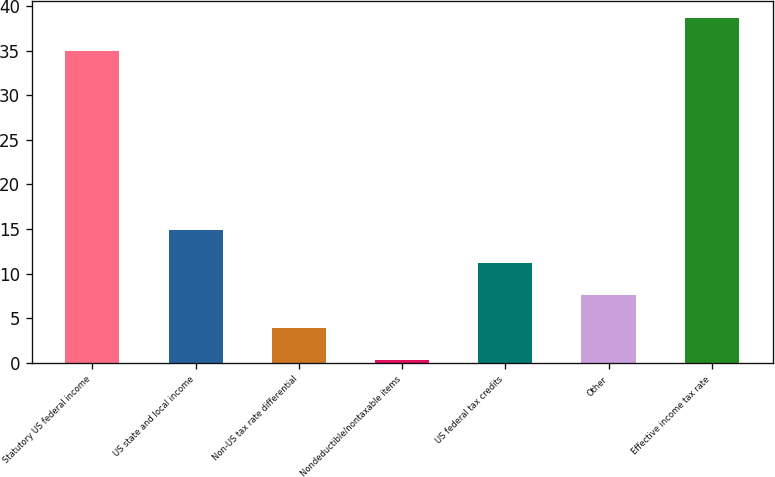<chart> <loc_0><loc_0><loc_500><loc_500><bar_chart><fcel>Statutory US federal income<fcel>US state and local income<fcel>Non-US tax rate differential<fcel>Nondeductible/nontaxable items<fcel>US federal tax credits<fcel>Other<fcel>Effective income tax rate<nl><fcel>35<fcel>14.9<fcel>3.95<fcel>0.3<fcel>11.25<fcel>7.6<fcel>38.65<nl></chart> 